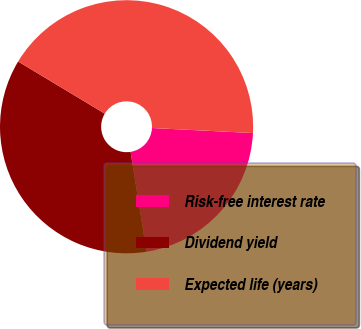Convert chart to OTSL. <chart><loc_0><loc_0><loc_500><loc_500><pie_chart><fcel>Risk-free interest rate<fcel>Dividend yield<fcel>Expected life (years)<nl><fcel>21.69%<fcel>36.14%<fcel>42.17%<nl></chart> 